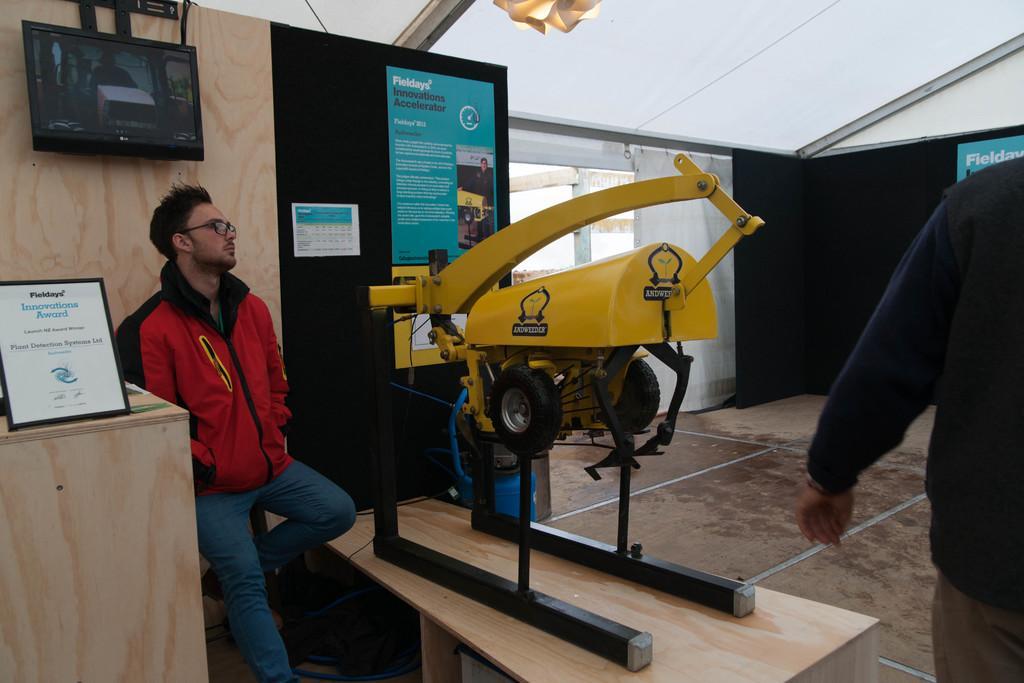Can you describe this image briefly? I can see in this image a man is standing on the floor beside the table. I can see there is a TV on the wall and a machine on the table. 